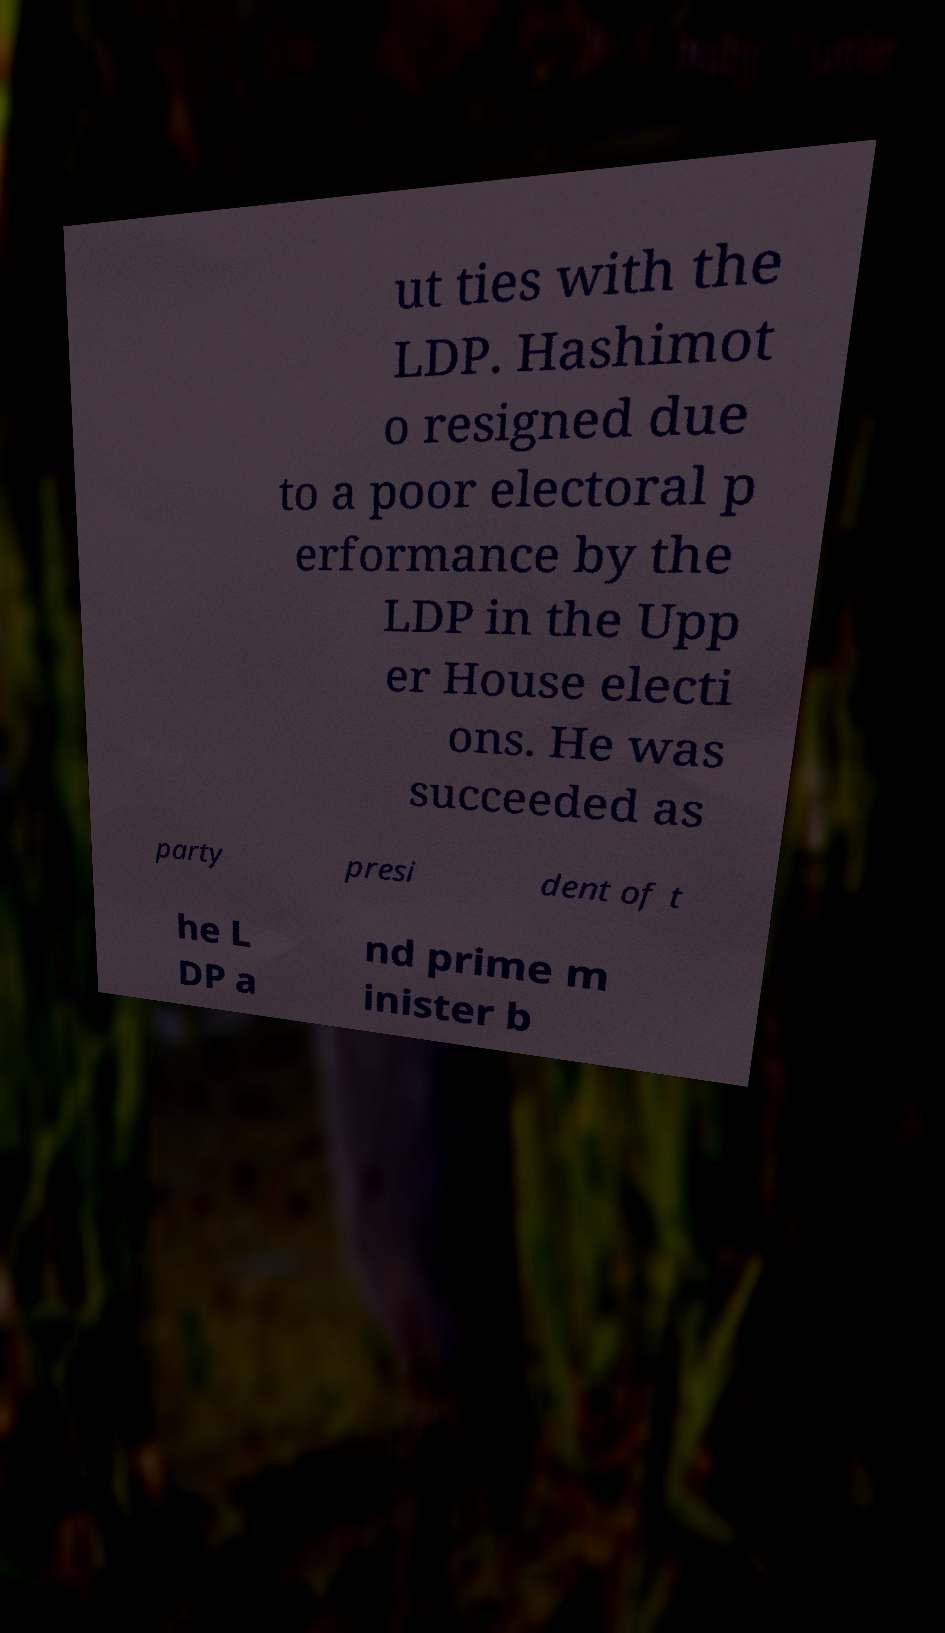There's text embedded in this image that I need extracted. Can you transcribe it verbatim? ut ties with the LDP. Hashimot o resigned due to a poor electoral p erformance by the LDP in the Upp er House electi ons. He was succeeded as party presi dent of t he L DP a nd prime m inister b 